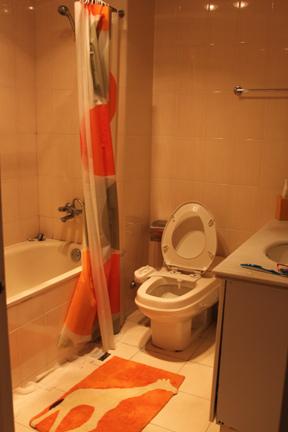Is there a tree in the image?
Quick response, please. No. Is the seat up?
Be succinct. Yes. What room is this?
Answer briefly. Bathroom. What animal is shown on the rug?
Short answer required. Giraffe. 